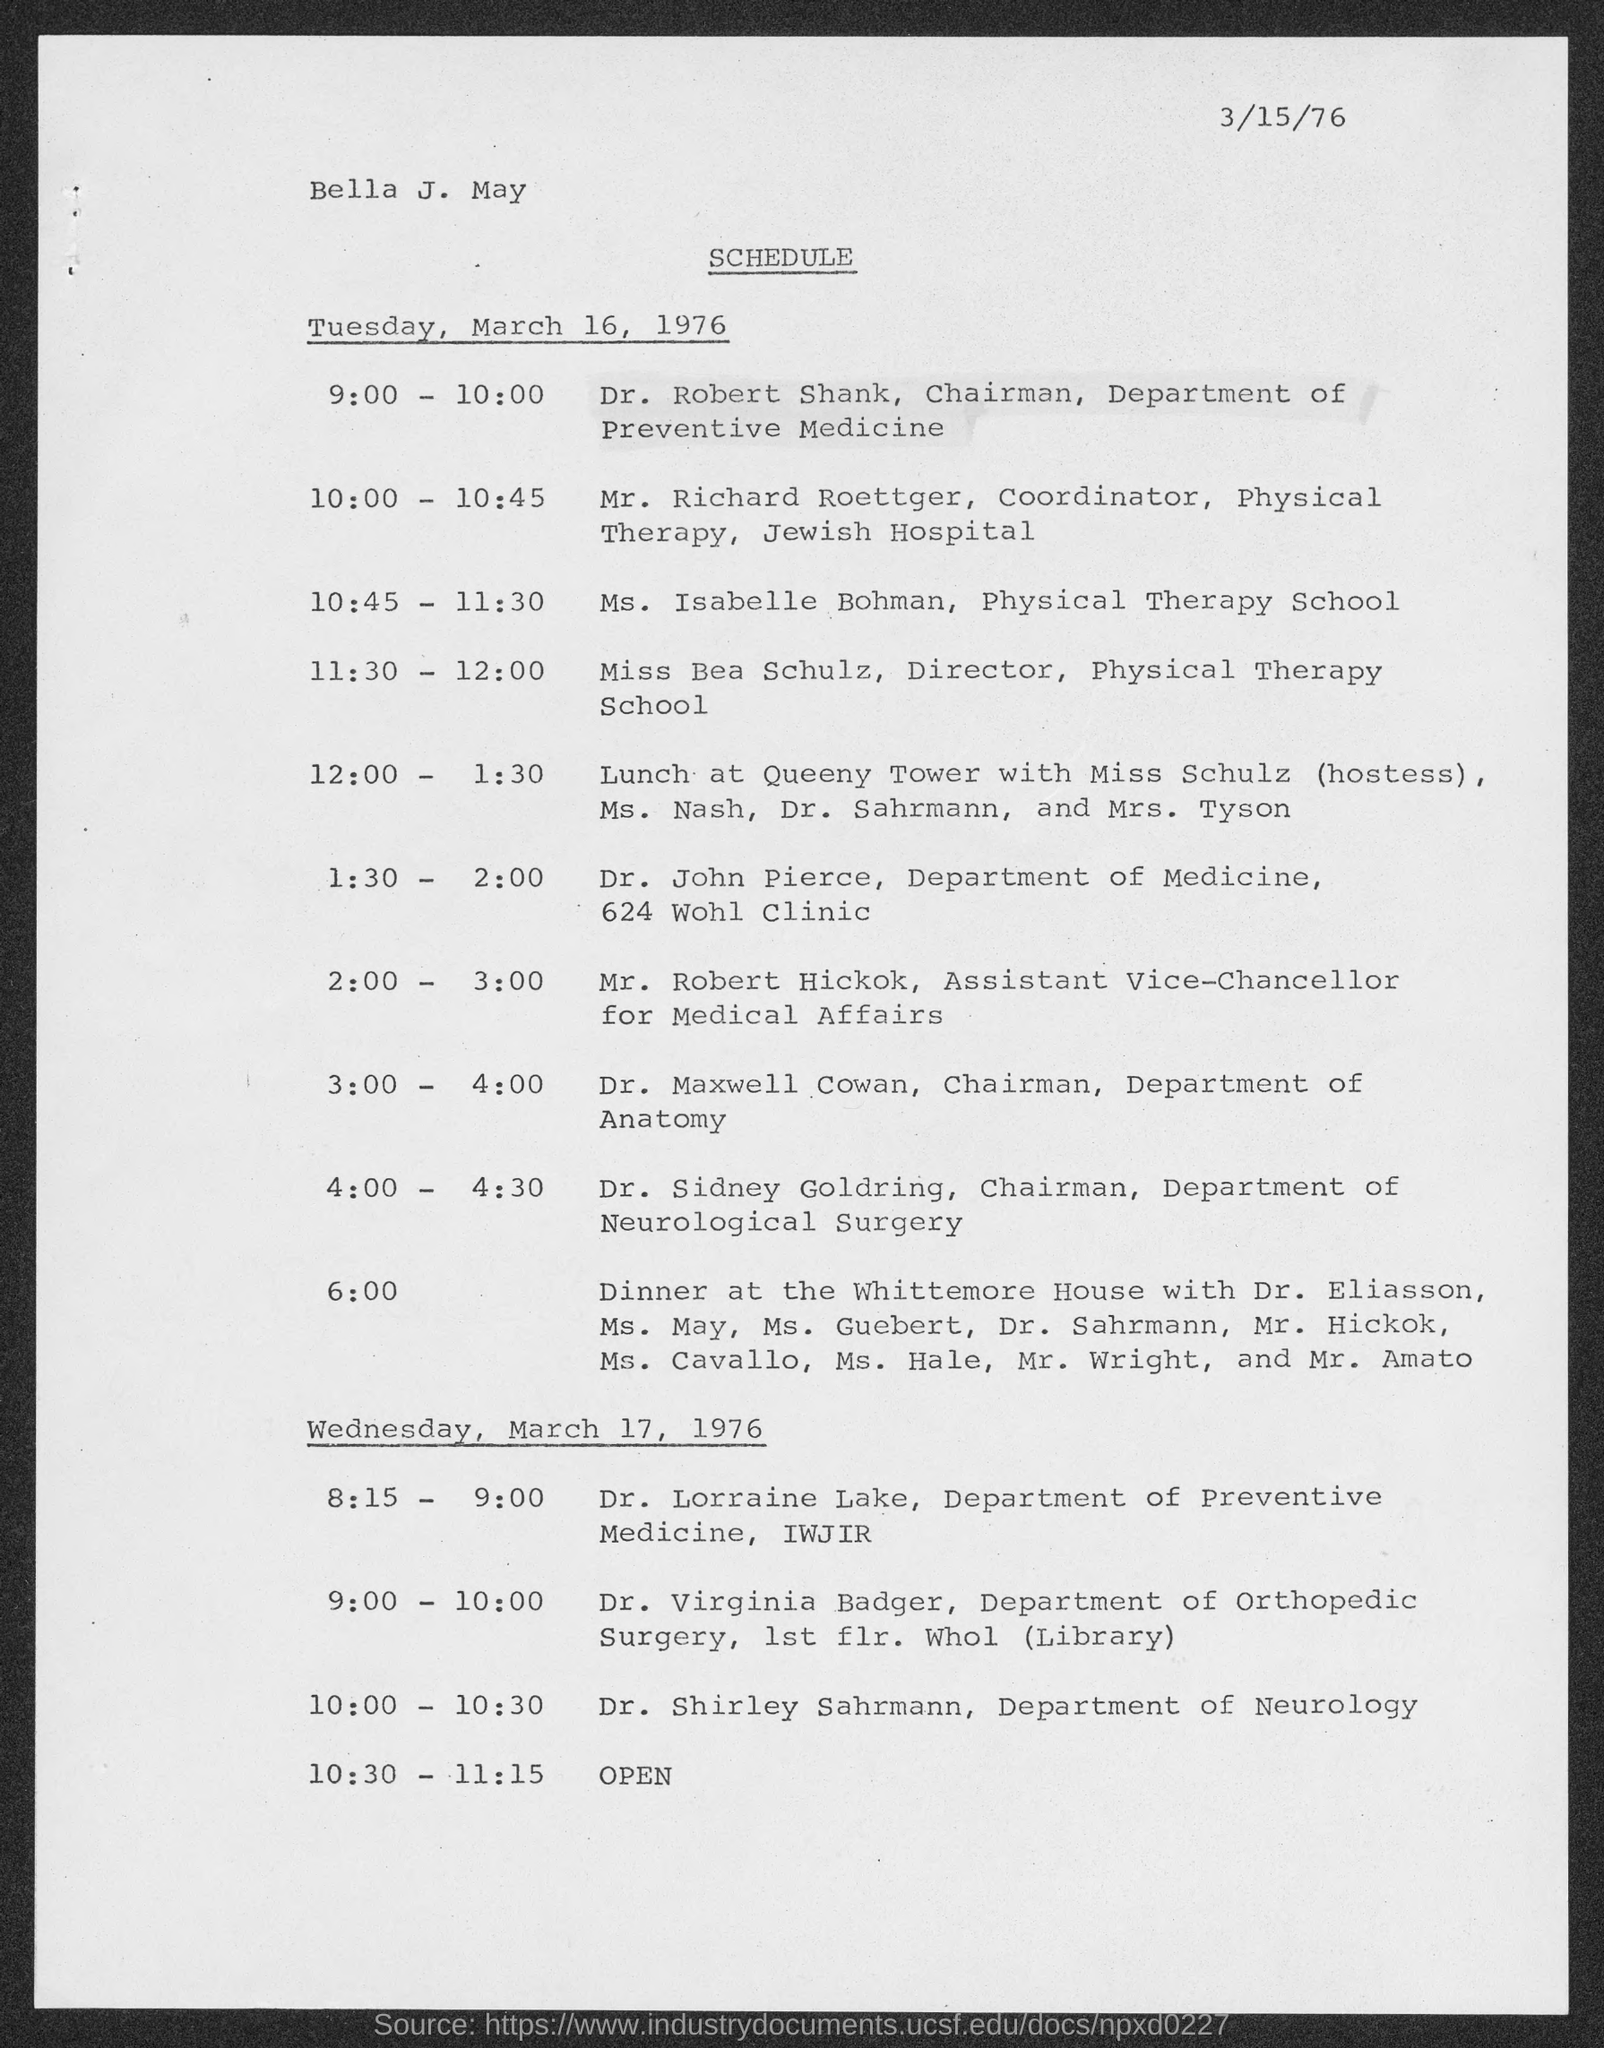What is the position of dr. robert shank?
Offer a very short reply. Chairman, Department of Preventive Medicine. What is the position of mr. richard roettger ?
Your answer should be compact. Coordinator, Physical Therapy, Jewish Hospital. What is the position of miss bea schulz ?
Offer a very short reply. Director, Physical Therapy School. What is the position of mr. robert hickok ?
Give a very brief answer. Assistant Vice-Chancellor for Medical Affairs. What is the position of dr. maxwell cowan ?
Your answer should be very brief. Chairman, Department of Anatomy. What is the position of dr. sidney goldring ?
Offer a terse response. Chairman, Department of Neurological Surgery. 